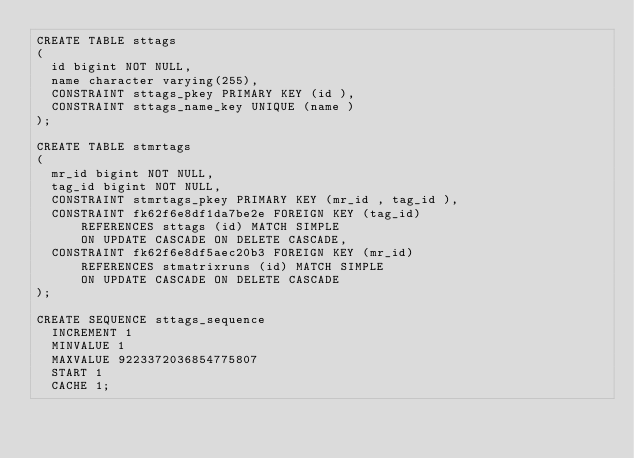Convert code to text. <code><loc_0><loc_0><loc_500><loc_500><_SQL_>CREATE TABLE sttags
(
  id bigint NOT NULL,
  name character varying(255),
  CONSTRAINT sttags_pkey PRIMARY KEY (id ),
  CONSTRAINT sttags_name_key UNIQUE (name )
);

CREATE TABLE stmrtags
(
  mr_id bigint NOT NULL,
  tag_id bigint NOT NULL,
  CONSTRAINT stmrtags_pkey PRIMARY KEY (mr_id , tag_id ),
  CONSTRAINT fk62f6e8df1da7be2e FOREIGN KEY (tag_id)
      REFERENCES sttags (id) MATCH SIMPLE
      ON UPDATE CASCADE ON DELETE CASCADE,
  CONSTRAINT fk62f6e8df5aec20b3 FOREIGN KEY (mr_id)
      REFERENCES stmatrixruns (id) MATCH SIMPLE
      ON UPDATE CASCADE ON DELETE CASCADE
);

CREATE SEQUENCE sttags_sequence
  INCREMENT 1
  MINVALUE 1
  MAXVALUE 9223372036854775807
  START 1
  CACHE 1;</code> 